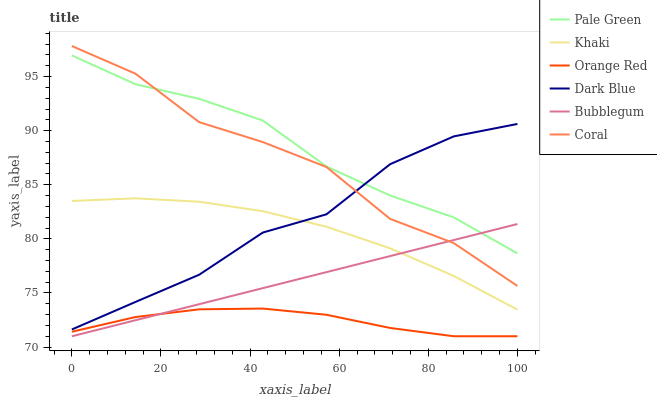Does Coral have the minimum area under the curve?
Answer yes or no. No. Does Coral have the maximum area under the curve?
Answer yes or no. No. Is Coral the smoothest?
Answer yes or no. No. Is Bubblegum the roughest?
Answer yes or no. No. Does Coral have the lowest value?
Answer yes or no. No. Does Bubblegum have the highest value?
Answer yes or no. No. Is Khaki less than Coral?
Answer yes or no. Yes. Is Khaki greater than Orange Red?
Answer yes or no. Yes. Does Khaki intersect Coral?
Answer yes or no. No. 